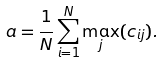Convert formula to latex. <formula><loc_0><loc_0><loc_500><loc_500>a = \frac { 1 } { N } \sum _ { i = 1 } ^ { N } \max _ { j } ( c _ { i j } ) .</formula> 